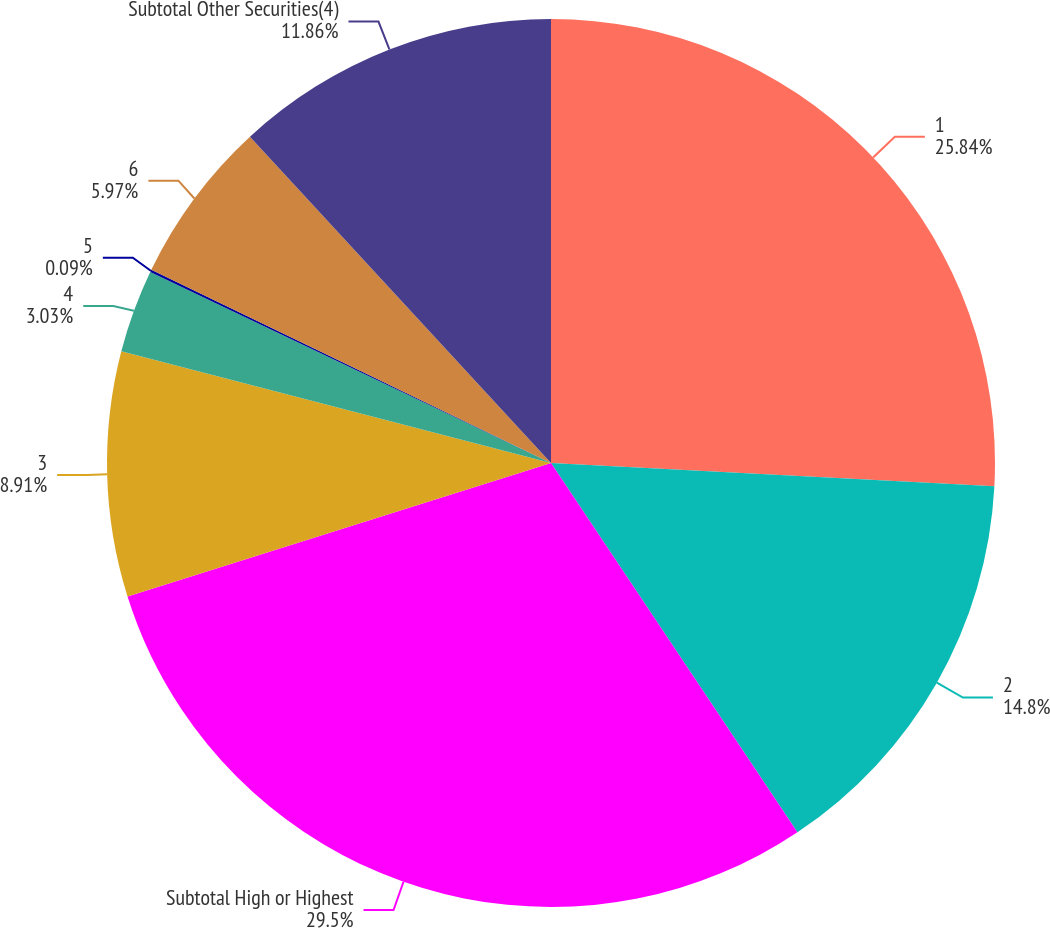Convert chart. <chart><loc_0><loc_0><loc_500><loc_500><pie_chart><fcel>1<fcel>2<fcel>Subtotal High or Highest<fcel>3<fcel>4<fcel>5<fcel>6<fcel>Subtotal Other Securities(4)<nl><fcel>25.84%<fcel>14.8%<fcel>29.51%<fcel>8.91%<fcel>3.03%<fcel>0.09%<fcel>5.97%<fcel>11.86%<nl></chart> 